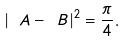Convert formula to latex. <formula><loc_0><loc_0><loc_500><loc_500>| \ A - \ B | ^ { 2 } = \frac { \pi } { 4 } .</formula> 